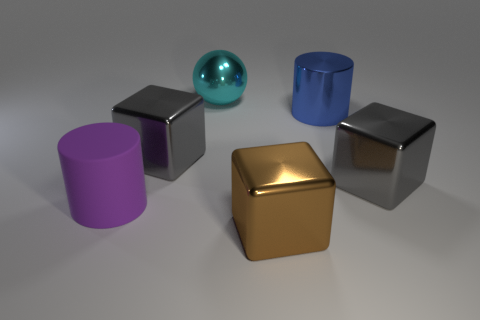There is a gray object to the left of the big cyan shiny ball; does it have the same shape as the large purple rubber object in front of the cyan thing?
Your answer should be very brief. No. Are the brown thing and the big gray cube on the left side of the blue cylinder made of the same material?
Your answer should be compact. Yes. What color is the big rubber cylinder?
Your answer should be compact. Purple. There is a cylinder that is to the left of the block that is left of the big brown cube; what number of objects are on the right side of it?
Offer a terse response. 5. Are there any big objects in front of the big rubber cylinder?
Your answer should be compact. Yes. How many objects are the same material as the big brown cube?
Provide a short and direct response. 4. How many objects are small cyan metal cylinders or rubber cylinders?
Your answer should be very brief. 1. Are any tiny gray shiny cylinders visible?
Your response must be concise. No. There is a large gray thing on the right side of the cyan thing behind the gray thing on the right side of the large cyan ball; what is it made of?
Your answer should be very brief. Metal. Are there fewer objects to the right of the big purple rubber cylinder than rubber cubes?
Offer a very short reply. No. 